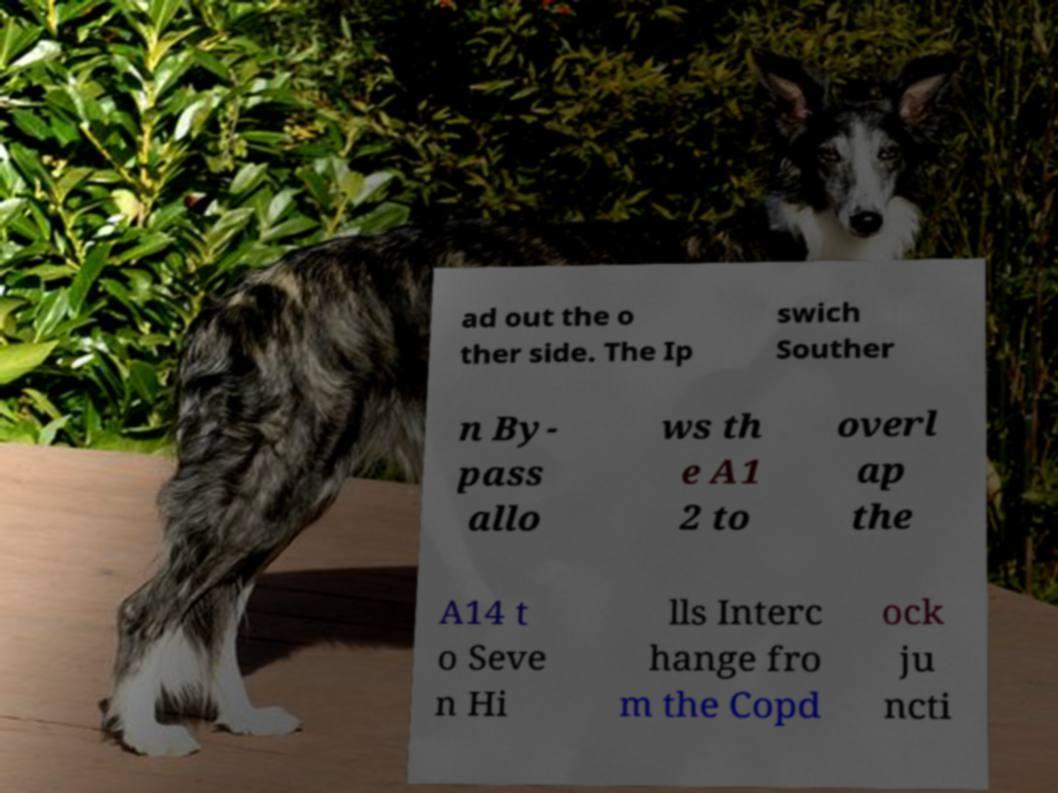Could you assist in decoding the text presented in this image and type it out clearly? ad out the o ther side. The Ip swich Souther n By- pass allo ws th e A1 2 to overl ap the A14 t o Seve n Hi lls Interc hange fro m the Copd ock ju ncti 